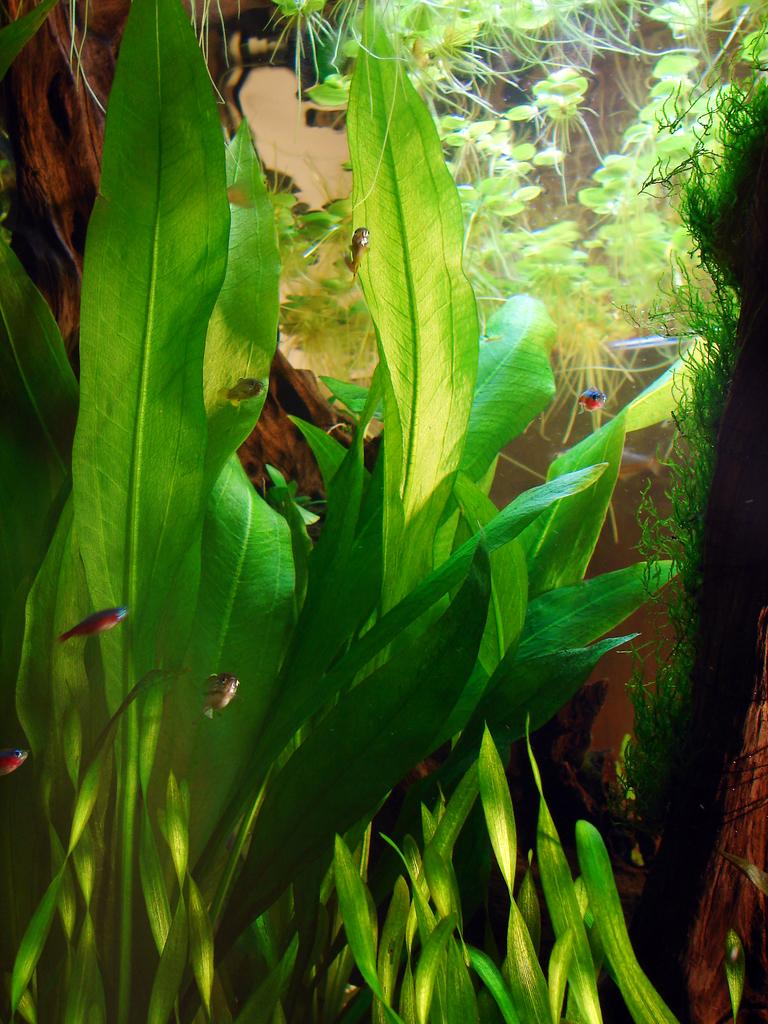What is located in the center of the image? There are leaves and trees in the center of the image. Can you describe the trees in the image? The trees in the image are surrounded by leaves. How does the crowd in the image compare to the crowd in the previous image? There is no crowd present in the image, as it only features leaves and trees. 